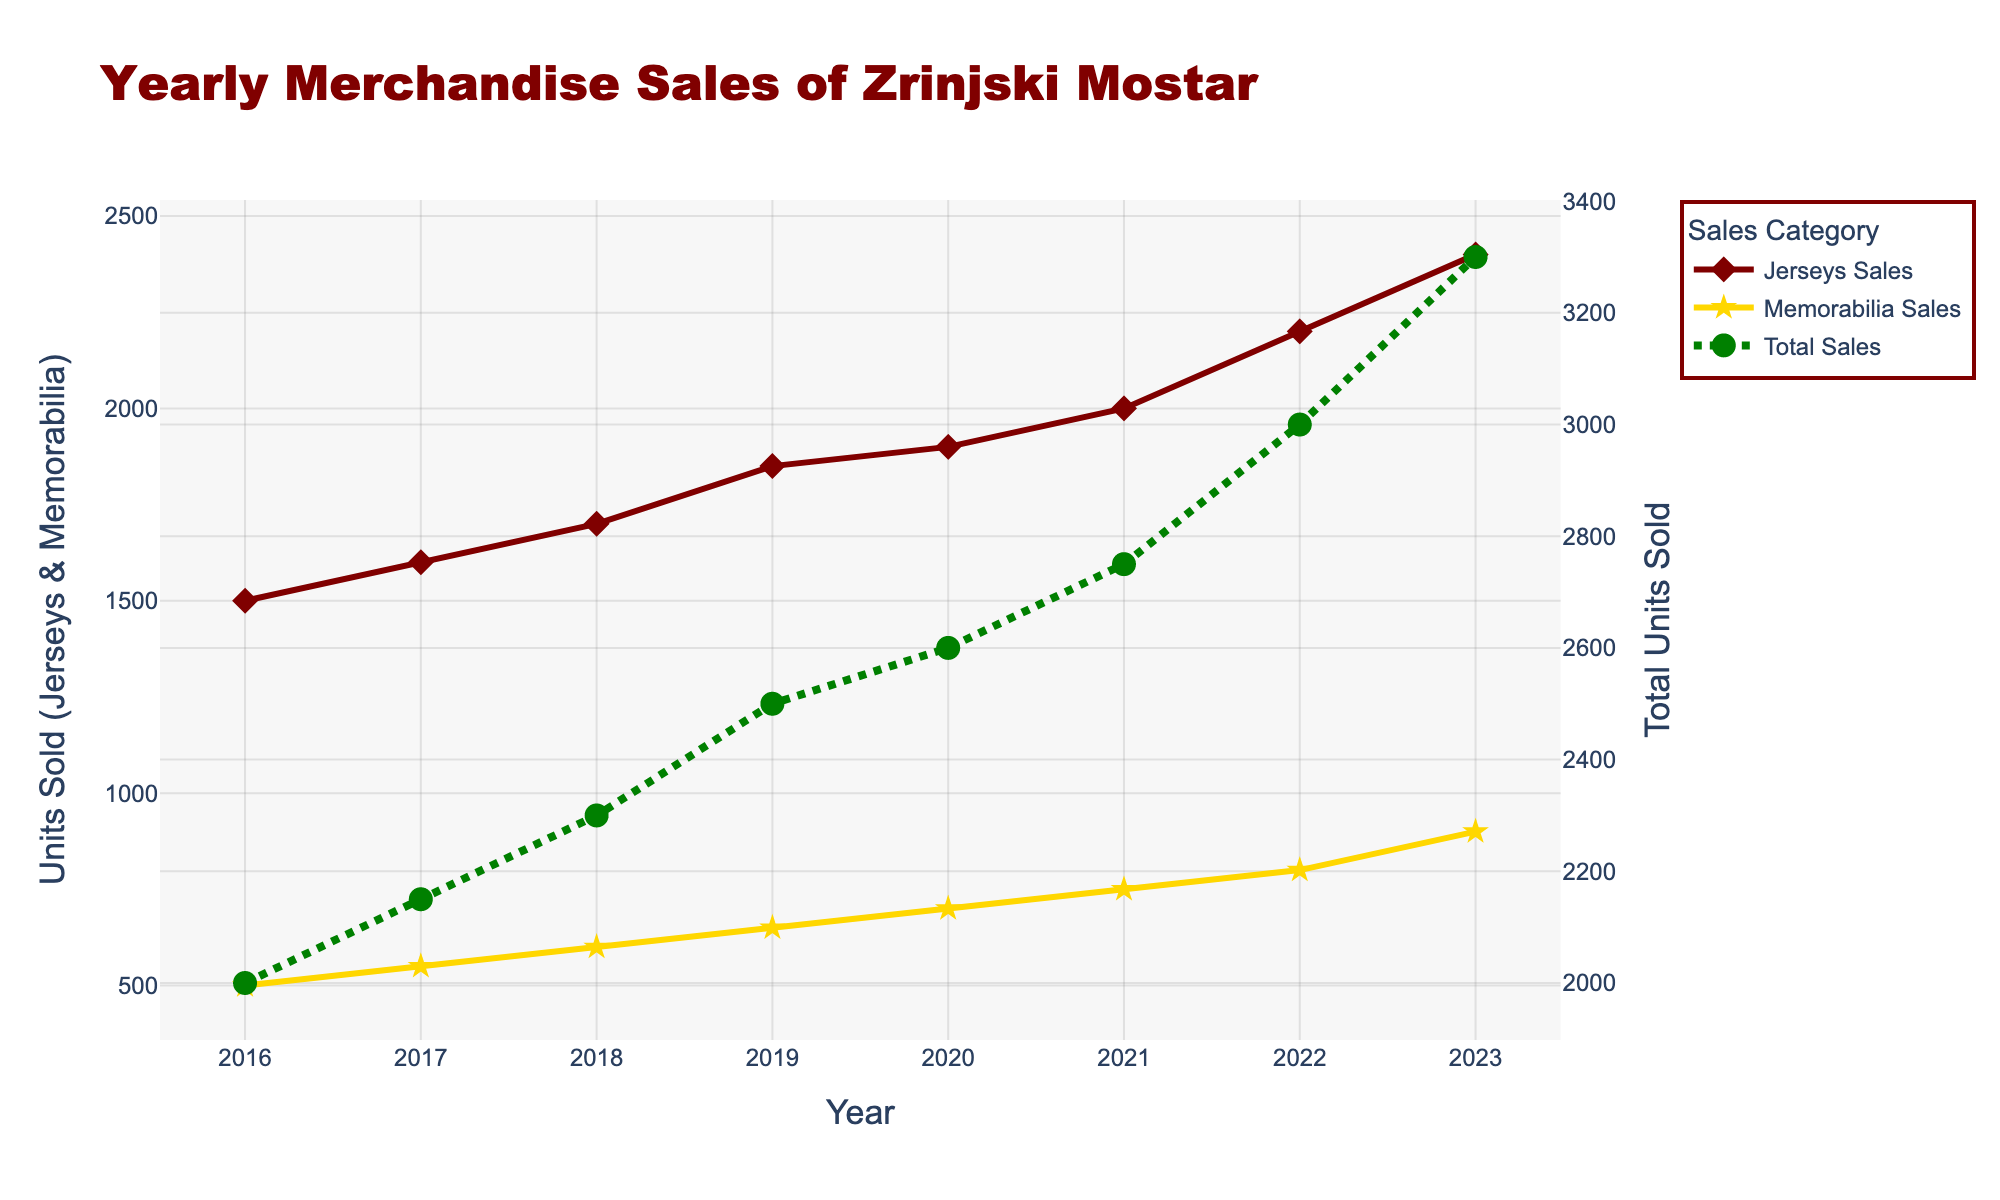What is the title of the plot? The title is located at the top center of the plot. It can be read directly from the plot.
Answer: Yearly Merchandise Sales of Zrinjski Mostar How many different sales categories are plotted? By looking at the legend, we can see there are three different sales categories: Jerseys Sales, Memorabilia Sales, and Total Sales.
Answer: Three What is the highest number of jerseys sold in a single year? By examining the data points in the 'Jerseys Sales (units)' trace, the highest value corresponds to the year 2023 with a value of 2400 units.
Answer: 2400 units In which year did Memorabilia Sales first reach at least 700 units? By tracing the 'Memorabilia Sales (units)' line, we see that the Memorabilia Sales first reached 700 units in the year 2020.
Answer: 2020 Compare the units sold for Jerseys and Memorabilia in 2019. Which was higher and by how much? By looking at the values for the year 2019 in the respective traces, Jerseys Sales were 1850 units and Memorabilia Sales were 650 units. The difference is 1850 - 650 = 1200 units.
Answer: Jerseys by 1200 units How many years did it take for the Total Sales to increase from 2000 to 3000 units? The Total Sales were at 2000 units in 2016 and reached 3000 units in 2022. Therefore, it took 2022 - 2016 = 6 years.
Answer: 6 years What is the total increase in Jerseys Sales from 2016 to 2023? The Jerseys Sales in 2016 were 1500 units and in 2023 were 2400 units. The increase is 2400 - 1500 = 900 units.
Answer: 900 units Between which two consecutive years did Memorabilia Sales show the maximum increase? By comparing the increments year by year in the Memorabilia Sales trace, the maximum increase occurred between 2022 and 2023, where the sales increased by 900 - 800 = 100 units.
Answer: 2022 to 2023 Is there any year when the Total Sales line intersects with the Jerseys Sales or Memorabilia Sales lines? By examining the plot, the Total Sales trace does not intersect with either the Jerseys Sales or Memorabilia Sales traces in any year.
Answer: No What can be said about the trend of Total Sales over the years? From the plot, the Total Sales show a consistently increasing trend from 2016 to 2023.
Answer: Increasing trend 